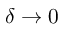Convert formula to latex. <formula><loc_0><loc_0><loc_500><loc_500>\delta \rightarrow 0</formula> 